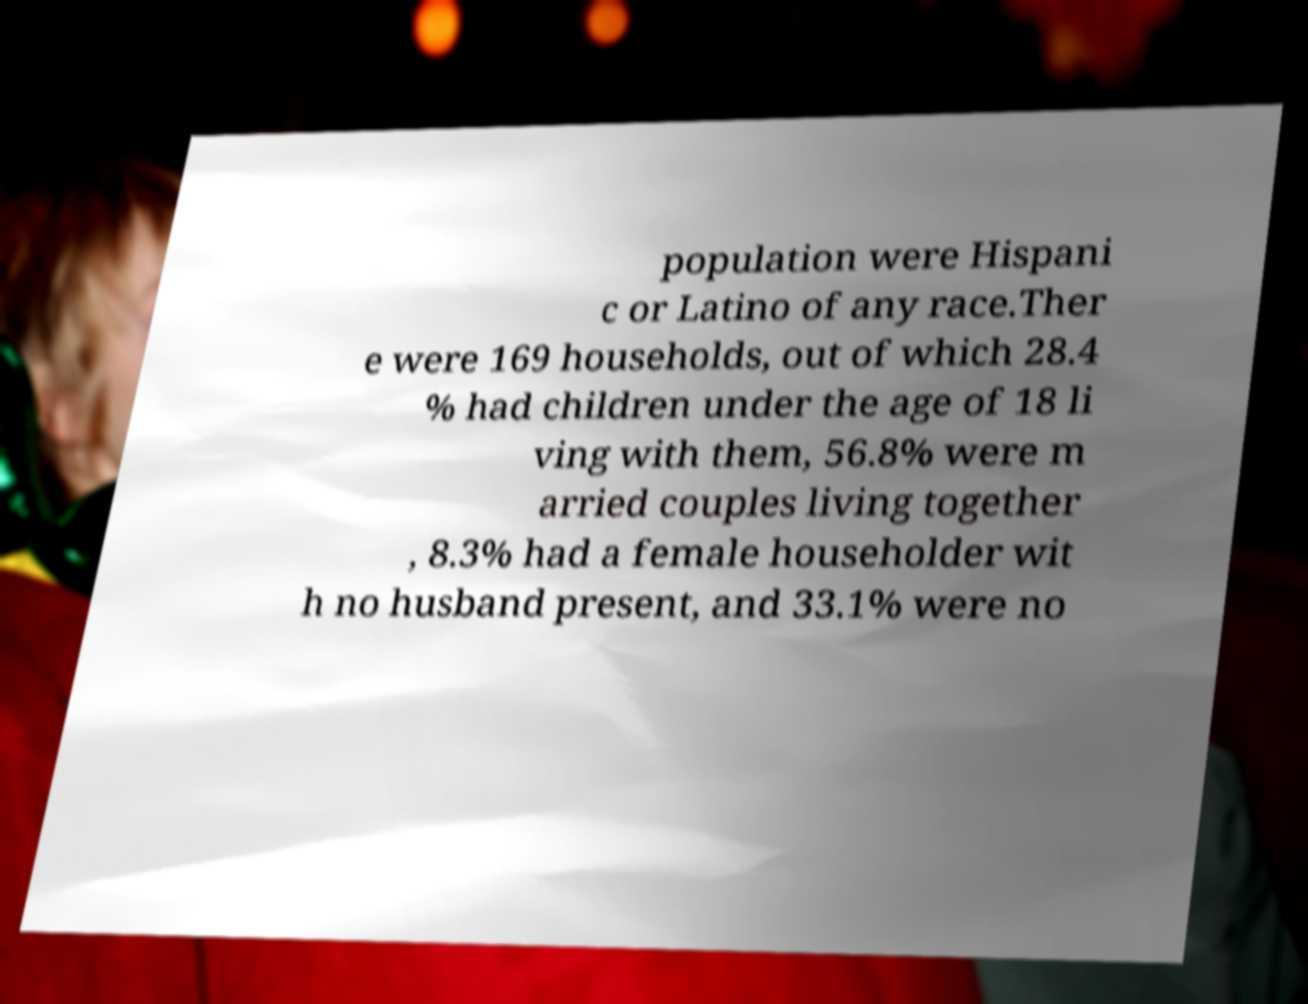I need the written content from this picture converted into text. Can you do that? population were Hispani c or Latino of any race.Ther e were 169 households, out of which 28.4 % had children under the age of 18 li ving with them, 56.8% were m arried couples living together , 8.3% had a female householder wit h no husband present, and 33.1% were no 